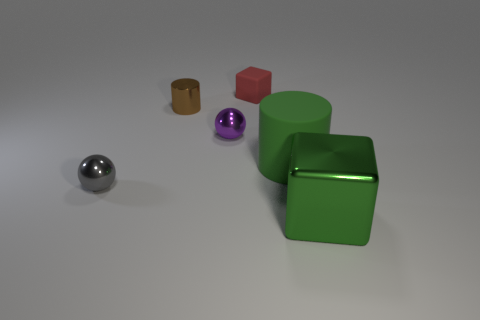Add 2 blue balls. How many objects exist? 8 Subtract all balls. How many objects are left? 4 Subtract all gray spheres. Subtract all small brown metal cylinders. How many objects are left? 4 Add 5 red things. How many red things are left? 6 Add 6 big green blocks. How many big green blocks exist? 7 Subtract 0 yellow blocks. How many objects are left? 6 